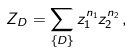<formula> <loc_0><loc_0><loc_500><loc_500>Z _ { D } = \sum _ { \{ D \} } z _ { 1 } ^ { n _ { 1 } } z _ { 2 } ^ { n _ { 2 } } \, ,</formula> 